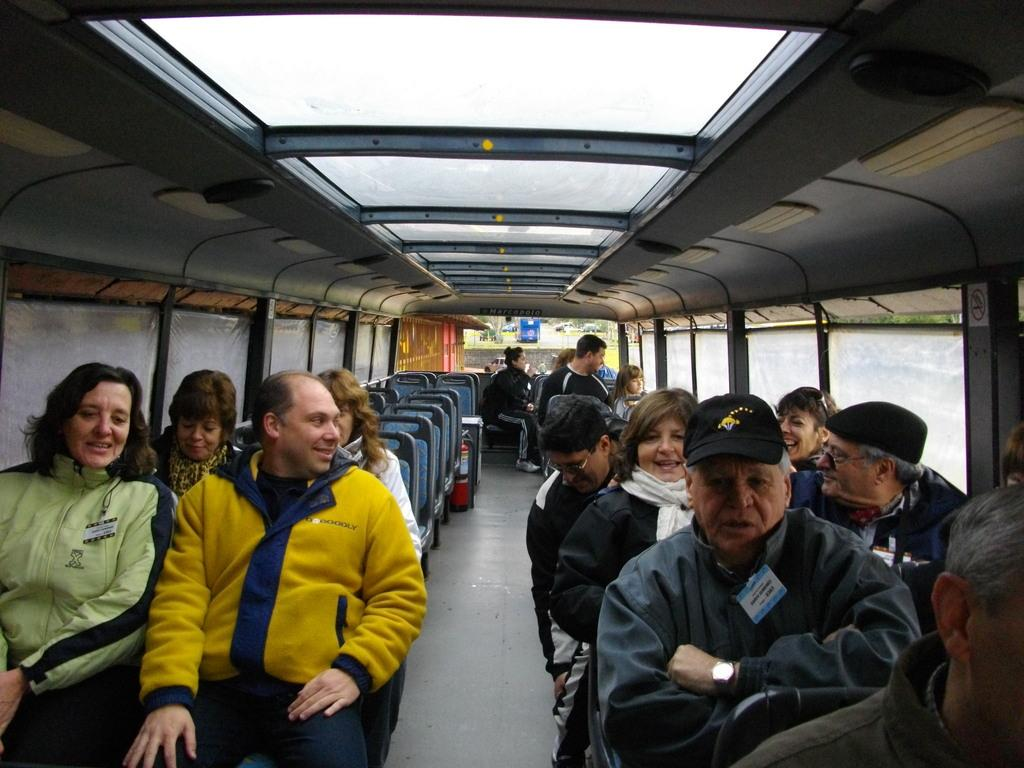How many people are in the image? There is a group of people in the image. What are the people doing in the image? The people are sitting on chairs. What type of vehicle is visible in the image? There is an inside part of a vehicle visible in the image. What is the material of the windows on both sides of the image? There are glass windows on the left side and the right side of the image. What type of sponge can be seen on the floor of the vehicle in the image? There is no sponge visible on the floor of the vehicle in the image. Can you tell me how many horses are present in the image? There are no horses present in the image. 